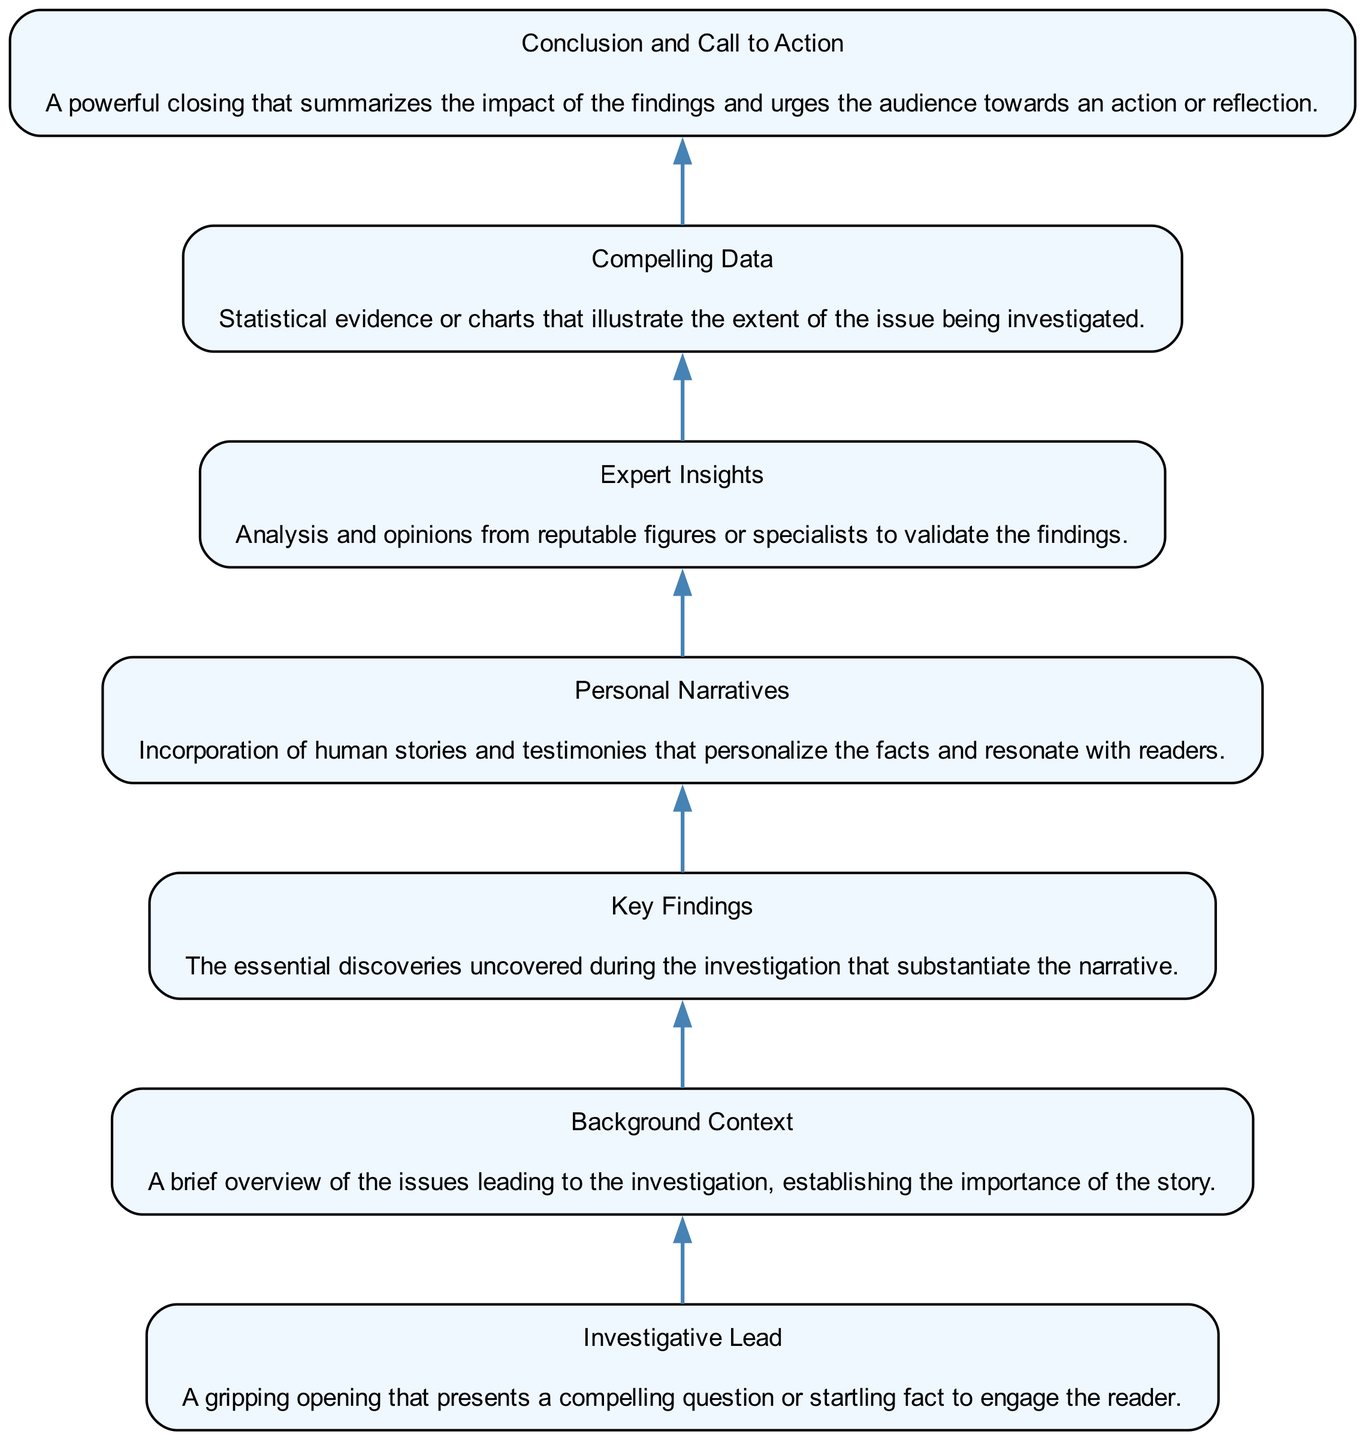What's the first element in the diagram? The first element listed in the diagram is "Investigative Lead." Since the flow is structured from bottom to top, this is the starting point.
Answer: Investigative Lead How many nodes are present in the diagram? There are a total of seven nodes in the diagram, representing different components of a compelling narrative structure. Each element corresponds to one node.
Answer: Seven What element follows "Key Findings"? "Personal Narratives" directly follows "Key Findings" as per the structure of the flow. This shows a progression from findings to human stories.
Answer: Personal Narratives What is the last element in the diagram? The last element at the end of the flow chart is "Conclusion and Call to Action," which summarizes the findings and prompts an action.
Answer: Conclusion and Call to Action Identify the connection between "Expert Insights" and "Compelling Data." "Compelling Data" comes after "Expert Insights," indicating that the insights provided help establish or validate the data that follows in the narrative.
Answer: Sequential connection How many layers of elements are in the flow chart? The diagram has a single layer as it flows from the bottom upwards without any branching. Each element transitions to the next in a linear fashion.
Answer: One layer Which element directly leads to the "Conclusion and Call to Action"? "Compelling Data" directly leads to the "Conclusion and Call to Action," showing that the data culminates in a summarizing and impactful conclusion.
Answer: Compelling Data What type of narrative is emphasized before presenting the "Key Findings"? The diagram emphasizes "Personal Narratives" before the "Key Findings," which suggests a focus on human experiences prior to discussing the investigation results.
Answer: Personal Narratives How does the "Background Context" relate to the "Investigative Lead"? The "Background Context" provides essential issues leading to the investigation, which aids in comprehending the significance of the story introduced by the "Investigative Lead."
Answer: Contextual connection 